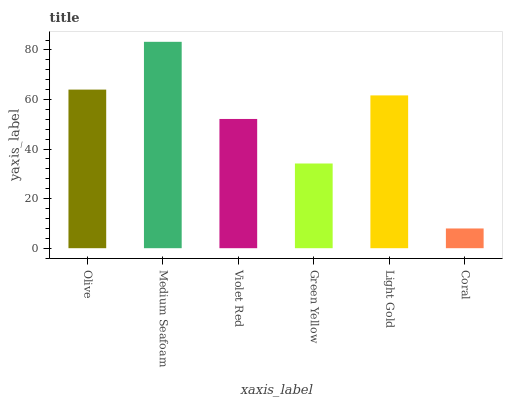Is Coral the minimum?
Answer yes or no. Yes. Is Medium Seafoam the maximum?
Answer yes or no. Yes. Is Violet Red the minimum?
Answer yes or no. No. Is Violet Red the maximum?
Answer yes or no. No. Is Medium Seafoam greater than Violet Red?
Answer yes or no. Yes. Is Violet Red less than Medium Seafoam?
Answer yes or no. Yes. Is Violet Red greater than Medium Seafoam?
Answer yes or no. No. Is Medium Seafoam less than Violet Red?
Answer yes or no. No. Is Light Gold the high median?
Answer yes or no. Yes. Is Violet Red the low median?
Answer yes or no. Yes. Is Medium Seafoam the high median?
Answer yes or no. No. Is Coral the low median?
Answer yes or no. No. 